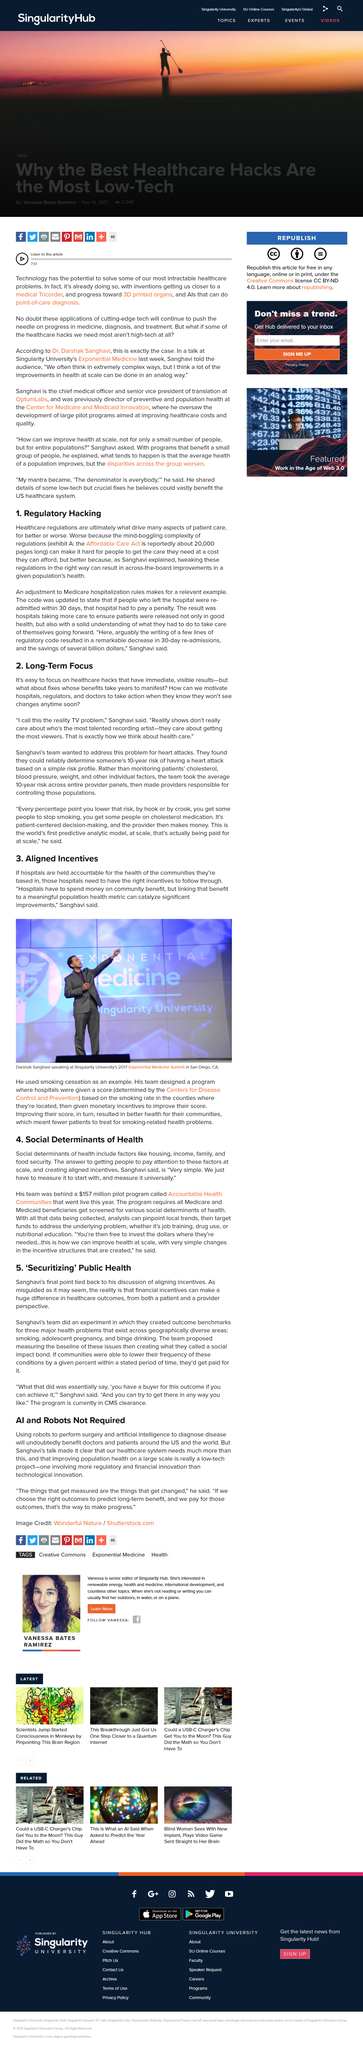Indicate a few pertinent items in this graphic. The team decided to address a problem found within the heart of the body. The Affordable Care Act is approximately 20,000 pages in length. The program was designed by a hospital team whose score was based on their country's smoking rate, as stated by Dr. Sanghavi. The implementation of a few lines of regulatory code led to a significant reduction in re-admissions, with the average time of decrease ranging from 30 days. Singularity University held the Exponential Medicine Summit in 2017. 